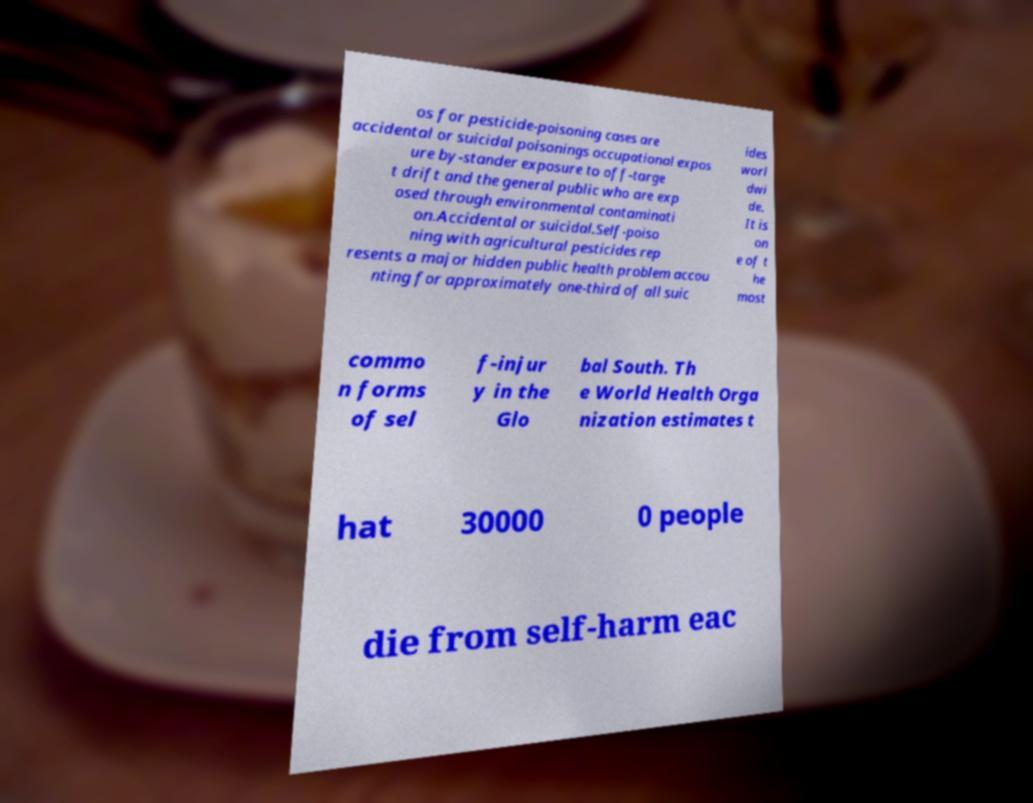Can you accurately transcribe the text from the provided image for me? os for pesticide-poisoning cases are accidental or suicidal poisonings occupational expos ure by-stander exposure to off-targe t drift and the general public who are exp osed through environmental contaminati on.Accidental or suicidal.Self-poiso ning with agricultural pesticides rep resents a major hidden public health problem accou nting for approximately one-third of all suic ides worl dwi de. It is on e of t he most commo n forms of sel f-injur y in the Glo bal South. Th e World Health Orga nization estimates t hat 30000 0 people die from self-harm eac 